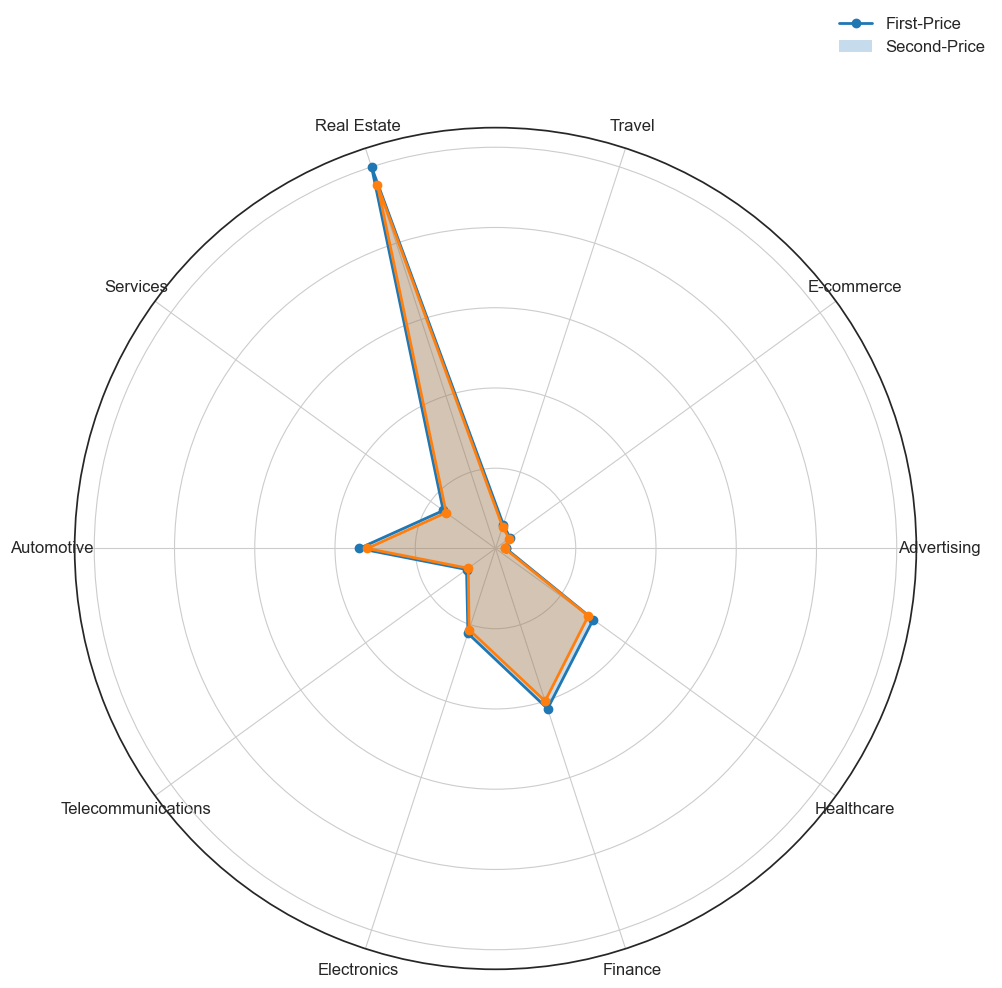Which industry has the highest average bid amount for first-price auctions? By examining the plot, we can see that the first-price bid amounts are marked on the radar chart. The industry with the largest value on the first-price plot is Real Estate.
Answer: Real Estate How does the average bid amount for first-price auctions compare between the Automotive and Electronics industries? To compare the average bid amounts, look at the values on the radar chart for first-price auctions. The Automotive industry's point is at 85.00, and the Electronics industry's point is at 55.60. Thus, the Automotive industry has a higher average bid amount than the Electronics industry.
Answer: Automotive > Electronics What is the difference in average bid amount for second-price auctions between the Healthcare and Finance industries? Find the respective points for Healthcare and Finance on the radar chart under the second-price auctions. For Healthcare, it is 71.50, and for Finance, it is 100.00. The difference is 100.00 - 71.50.
Answer: 28.50 By how much do the average bid amounts differ for first-price and second-price auctions in the Travel industry? Look at the Travel industry's points for both first-price and second-price auctions on the chart. For first-price, it is 15.70, and for second-price, it is 14.30. The difference is 15.70 - 14.30.
Answer: 1.40 Which auction type in Advertising has the higher average bid amount? Check the radar chart for the Advertising industry. The first-price auction is marked at 6.50, and the second-price auction is marked at 5.75. Thus, the first-price auction has the higher average bid amount.
Answer: First-Price What is the sum of average bid amounts for first-price auctions across all industries? Sum the values on the radar chart for first-price auctions. Adding 6.50 (Advertising) + 11.20 (E-commerce) + 15.70 (Travel) + 250.00 (Real Estate) + 40.25 (Services) + 85.00 (Automotive) + 22.30 (Telecommunications) + 55.60 (Electronics) + 105.00 (Finance) + 75.30 (Healthcare) gives 667.85.
Answer: 667.85 Which industry has the most significant difference between first-price and second-price auction average bid amounts? Calculate the difference between the average bid amounts for each industry on the radar chart. The differences are Advertising (0.75), E-commerce (0.70), Travel (1.40), Real Estate (12.00), Services (2.25), Automotive (5.00), Telecommunications (1.30), Electronics (2.40), Finance (5.00), and Healthcare (3.80). The largest difference is in Real Estate.
Answer: Real Estate 